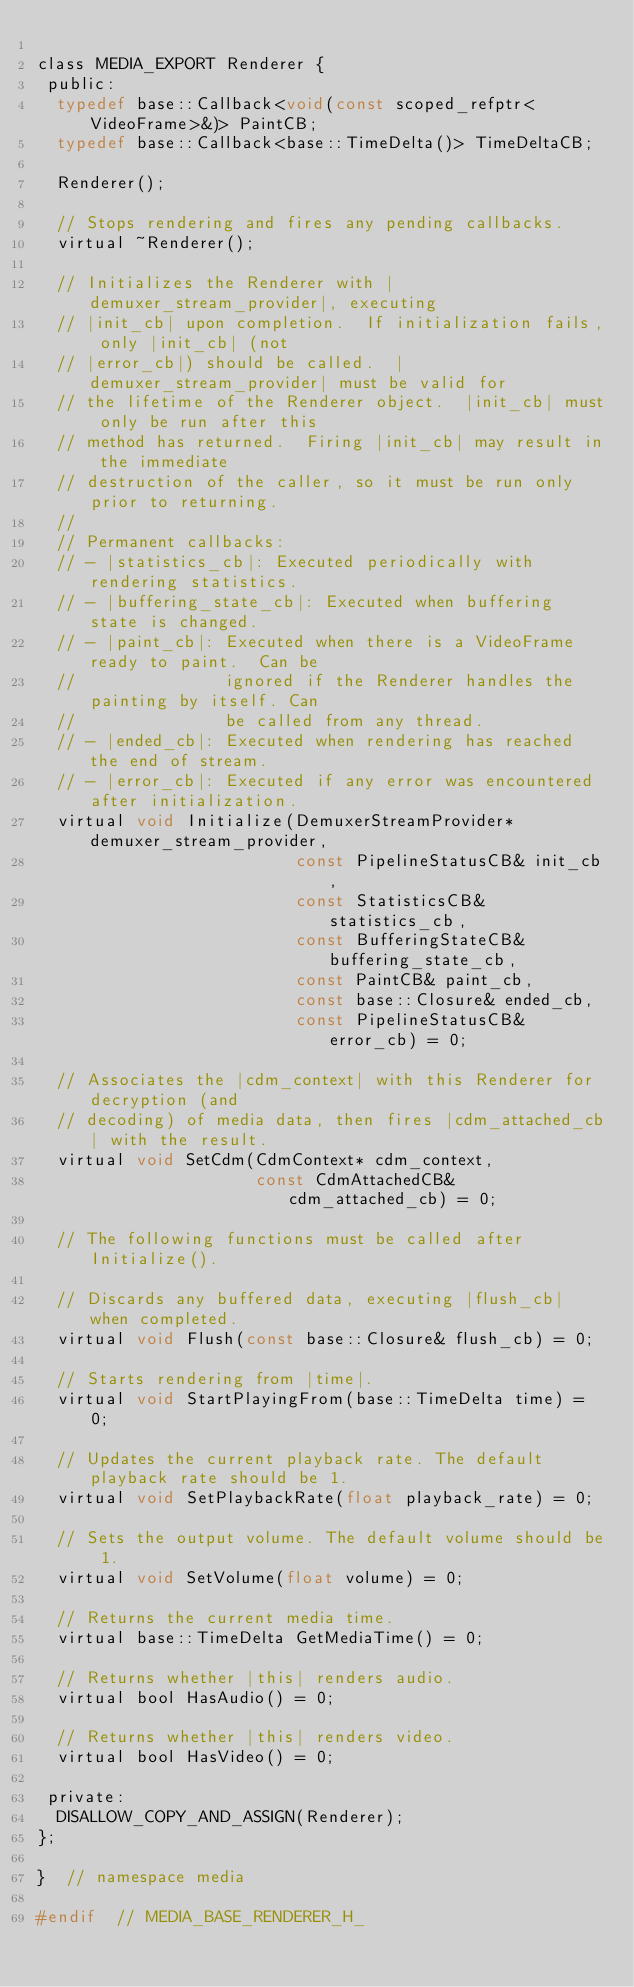Convert code to text. <code><loc_0><loc_0><loc_500><loc_500><_C_>
class MEDIA_EXPORT Renderer {
 public:
  typedef base::Callback<void(const scoped_refptr<VideoFrame>&)> PaintCB;
  typedef base::Callback<base::TimeDelta()> TimeDeltaCB;

  Renderer();

  // Stops rendering and fires any pending callbacks.
  virtual ~Renderer();

  // Initializes the Renderer with |demuxer_stream_provider|, executing
  // |init_cb| upon completion.  If initialization fails, only |init_cb| (not
  // |error_cb|) should be called.  |demuxer_stream_provider| must be valid for
  // the lifetime of the Renderer object.  |init_cb| must only be run after this
  // method has returned.  Firing |init_cb| may result in the immediate
  // destruction of the caller, so it must be run only prior to returning.
  //
  // Permanent callbacks:
  // - |statistics_cb|: Executed periodically with rendering statistics.
  // - |buffering_state_cb|: Executed when buffering state is changed.
  // - |paint_cb|: Executed when there is a VideoFrame ready to paint.  Can be
  //               ignored if the Renderer handles the painting by itself. Can
  //               be called from any thread.
  // - |ended_cb|: Executed when rendering has reached the end of stream.
  // - |error_cb|: Executed if any error was encountered after initialization.
  virtual void Initialize(DemuxerStreamProvider* demuxer_stream_provider,
                          const PipelineStatusCB& init_cb,
                          const StatisticsCB& statistics_cb,
                          const BufferingStateCB& buffering_state_cb,
                          const PaintCB& paint_cb,
                          const base::Closure& ended_cb,
                          const PipelineStatusCB& error_cb) = 0;

  // Associates the |cdm_context| with this Renderer for decryption (and
  // decoding) of media data, then fires |cdm_attached_cb| with the result.
  virtual void SetCdm(CdmContext* cdm_context,
                      const CdmAttachedCB& cdm_attached_cb) = 0;

  // The following functions must be called after Initialize().

  // Discards any buffered data, executing |flush_cb| when completed.
  virtual void Flush(const base::Closure& flush_cb) = 0;

  // Starts rendering from |time|.
  virtual void StartPlayingFrom(base::TimeDelta time) = 0;

  // Updates the current playback rate. The default playback rate should be 1.
  virtual void SetPlaybackRate(float playback_rate) = 0;

  // Sets the output volume. The default volume should be 1.
  virtual void SetVolume(float volume) = 0;

  // Returns the current media time.
  virtual base::TimeDelta GetMediaTime() = 0;

  // Returns whether |this| renders audio.
  virtual bool HasAudio() = 0;

  // Returns whether |this| renders video.
  virtual bool HasVideo() = 0;

 private:
  DISALLOW_COPY_AND_ASSIGN(Renderer);
};

}  // namespace media

#endif  // MEDIA_BASE_RENDERER_H_
</code> 